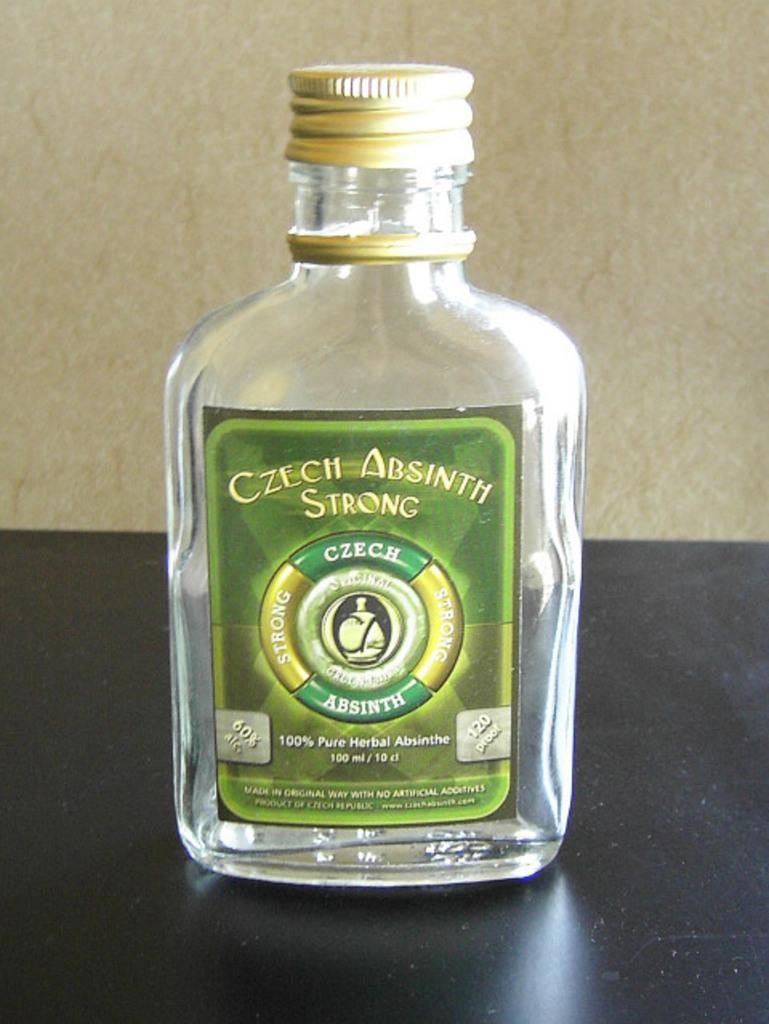<image>
Write a terse but informative summary of the picture. A bottle of Absinth  has a gold cap. 